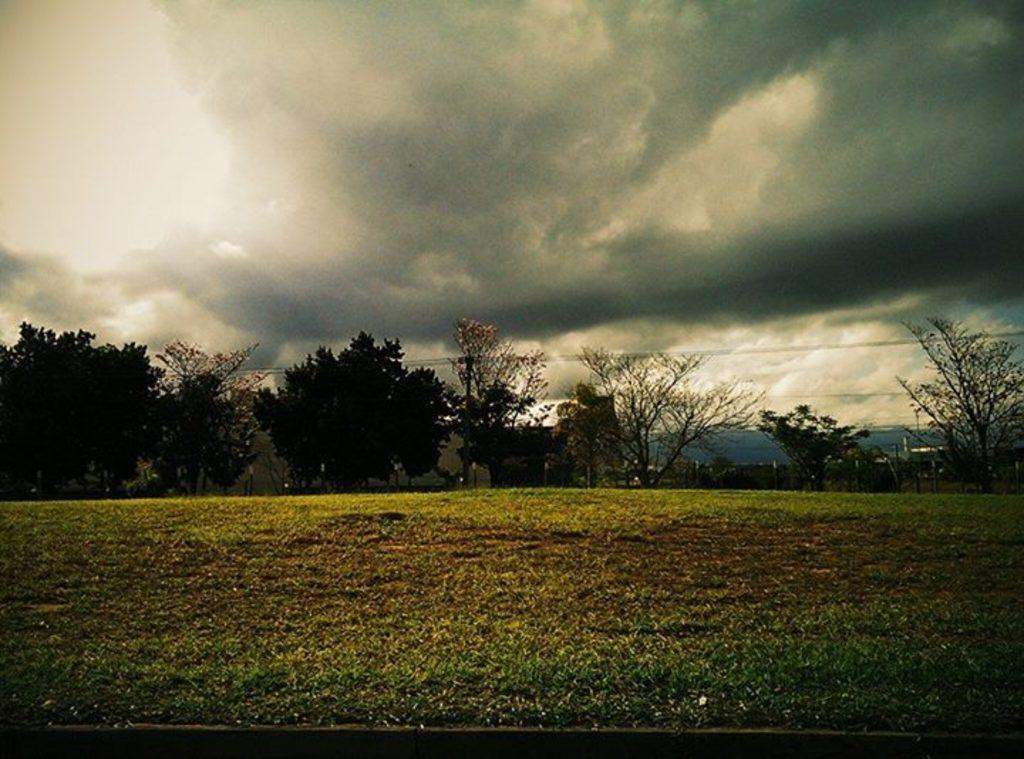What type of structures can be seen in the image? There are buildings in the image. What natural elements are present in the image? There is a group of trees, grass, and hills visible in the image. What man-made elements can be seen in the image? There is a fence and wires in the image. What is the condition of the sky in the image? The sky is visible in the image and appears cloudy. Where is the hospital located in the image? There is no hospital present in the image. What type of education can be seen being provided in the image? There is no educational activity visible in the image. 